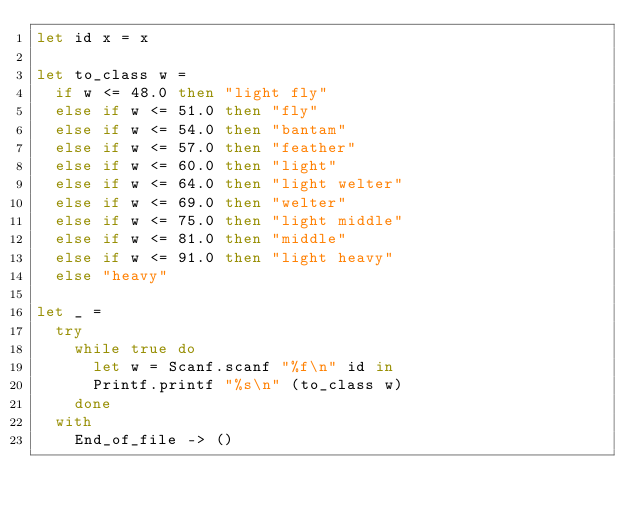Convert code to text. <code><loc_0><loc_0><loc_500><loc_500><_OCaml_>let id x = x

let to_class w =
  if w <= 48.0 then "light fly"
  else if w <= 51.0 then "fly"
  else if w <= 54.0 then "bantam"
  else if w <= 57.0 then "feather"
  else if w <= 60.0 then "light"
  else if w <= 64.0 then "light welter"
  else if w <= 69.0 then "welter"
  else if w <= 75.0 then "light middle"
  else if w <= 81.0 then "middle"
  else if w <= 91.0 then "light heavy"
  else "heavy"

let _ =
  try
    while true do
      let w = Scanf.scanf "%f\n" id in
      Printf.printf "%s\n" (to_class w)
    done
  with
    End_of_file -> ()</code> 